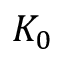<formula> <loc_0><loc_0><loc_500><loc_500>K _ { 0 }</formula> 